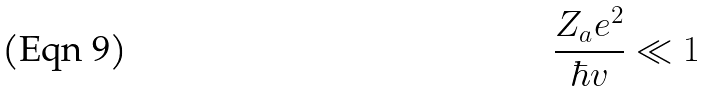Convert formula to latex. <formula><loc_0><loc_0><loc_500><loc_500>\frac { Z _ { a } e ^ { 2 } } { \hbar { v } } \ll 1</formula> 